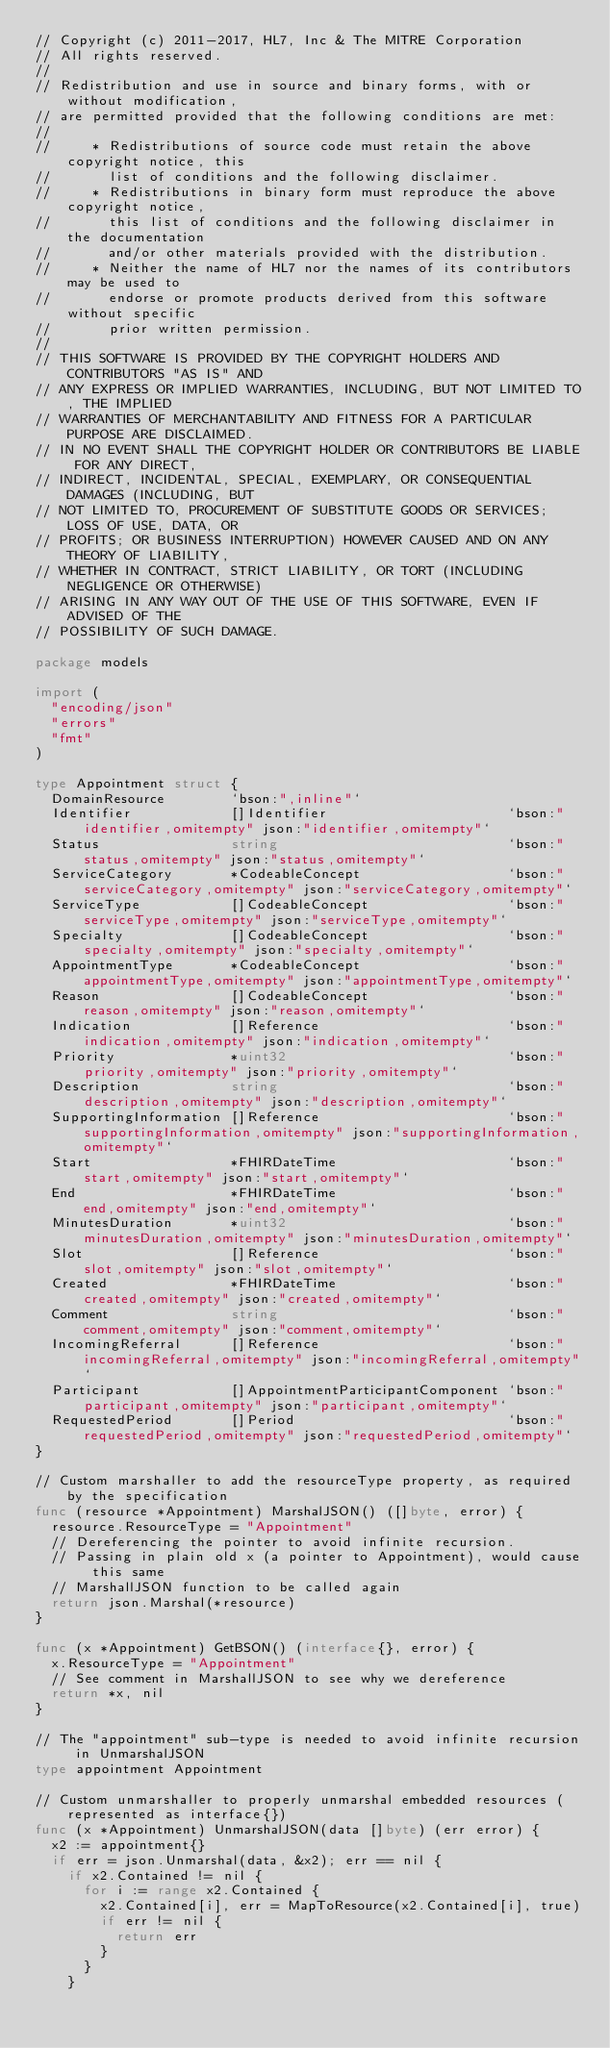Convert code to text. <code><loc_0><loc_0><loc_500><loc_500><_Go_>// Copyright (c) 2011-2017, HL7, Inc & The MITRE Corporation
// All rights reserved.
//
// Redistribution and use in source and binary forms, with or without modification,
// are permitted provided that the following conditions are met:
//
//     * Redistributions of source code must retain the above copyright notice, this
//       list of conditions and the following disclaimer.
//     * Redistributions in binary form must reproduce the above copyright notice,
//       this list of conditions and the following disclaimer in the documentation
//       and/or other materials provided with the distribution.
//     * Neither the name of HL7 nor the names of its contributors may be used to
//       endorse or promote products derived from this software without specific
//       prior written permission.
//
// THIS SOFTWARE IS PROVIDED BY THE COPYRIGHT HOLDERS AND CONTRIBUTORS "AS IS" AND
// ANY EXPRESS OR IMPLIED WARRANTIES, INCLUDING, BUT NOT LIMITED TO, THE IMPLIED
// WARRANTIES OF MERCHANTABILITY AND FITNESS FOR A PARTICULAR PURPOSE ARE DISCLAIMED.
// IN NO EVENT SHALL THE COPYRIGHT HOLDER OR CONTRIBUTORS BE LIABLE FOR ANY DIRECT,
// INDIRECT, INCIDENTAL, SPECIAL, EXEMPLARY, OR CONSEQUENTIAL DAMAGES (INCLUDING, BUT
// NOT LIMITED TO, PROCUREMENT OF SUBSTITUTE GOODS OR SERVICES; LOSS OF USE, DATA, OR
// PROFITS; OR BUSINESS INTERRUPTION) HOWEVER CAUSED AND ON ANY THEORY OF LIABILITY,
// WHETHER IN CONTRACT, STRICT LIABILITY, OR TORT (INCLUDING NEGLIGENCE OR OTHERWISE)
// ARISING IN ANY WAY OUT OF THE USE OF THIS SOFTWARE, EVEN IF ADVISED OF THE
// POSSIBILITY OF SUCH DAMAGE.

package models

import (
	"encoding/json"
	"errors"
	"fmt"
)

type Appointment struct {
	DomainResource        `bson:",inline"`
	Identifier            []Identifier                      `bson:"identifier,omitempty" json:"identifier,omitempty"`
	Status                string                            `bson:"status,omitempty" json:"status,omitempty"`
	ServiceCategory       *CodeableConcept                  `bson:"serviceCategory,omitempty" json:"serviceCategory,omitempty"`
	ServiceType           []CodeableConcept                 `bson:"serviceType,omitempty" json:"serviceType,omitempty"`
	Specialty             []CodeableConcept                 `bson:"specialty,omitempty" json:"specialty,omitempty"`
	AppointmentType       *CodeableConcept                  `bson:"appointmentType,omitempty" json:"appointmentType,omitempty"`
	Reason                []CodeableConcept                 `bson:"reason,omitempty" json:"reason,omitempty"`
	Indication            []Reference                       `bson:"indication,omitempty" json:"indication,omitempty"`
	Priority              *uint32                           `bson:"priority,omitempty" json:"priority,omitempty"`
	Description           string                            `bson:"description,omitempty" json:"description,omitempty"`
	SupportingInformation []Reference                       `bson:"supportingInformation,omitempty" json:"supportingInformation,omitempty"`
	Start                 *FHIRDateTime                     `bson:"start,omitempty" json:"start,omitempty"`
	End                   *FHIRDateTime                     `bson:"end,omitempty" json:"end,omitempty"`
	MinutesDuration       *uint32                           `bson:"minutesDuration,omitempty" json:"minutesDuration,omitempty"`
	Slot                  []Reference                       `bson:"slot,omitempty" json:"slot,omitempty"`
	Created               *FHIRDateTime                     `bson:"created,omitempty" json:"created,omitempty"`
	Comment               string                            `bson:"comment,omitempty" json:"comment,omitempty"`
	IncomingReferral      []Reference                       `bson:"incomingReferral,omitempty" json:"incomingReferral,omitempty"`
	Participant           []AppointmentParticipantComponent `bson:"participant,omitempty" json:"participant,omitempty"`
	RequestedPeriod       []Period                          `bson:"requestedPeriod,omitempty" json:"requestedPeriod,omitempty"`
}

// Custom marshaller to add the resourceType property, as required by the specification
func (resource *Appointment) MarshalJSON() ([]byte, error) {
	resource.ResourceType = "Appointment"
	// Dereferencing the pointer to avoid infinite recursion.
	// Passing in plain old x (a pointer to Appointment), would cause this same
	// MarshallJSON function to be called again
	return json.Marshal(*resource)
}

func (x *Appointment) GetBSON() (interface{}, error) {
	x.ResourceType = "Appointment"
	// See comment in MarshallJSON to see why we dereference
	return *x, nil
}

// The "appointment" sub-type is needed to avoid infinite recursion in UnmarshalJSON
type appointment Appointment

// Custom unmarshaller to properly unmarshal embedded resources (represented as interface{})
func (x *Appointment) UnmarshalJSON(data []byte) (err error) {
	x2 := appointment{}
	if err = json.Unmarshal(data, &x2); err == nil {
		if x2.Contained != nil {
			for i := range x2.Contained {
				x2.Contained[i], err = MapToResource(x2.Contained[i], true)
				if err != nil {
					return err
				}
			}
		}</code> 